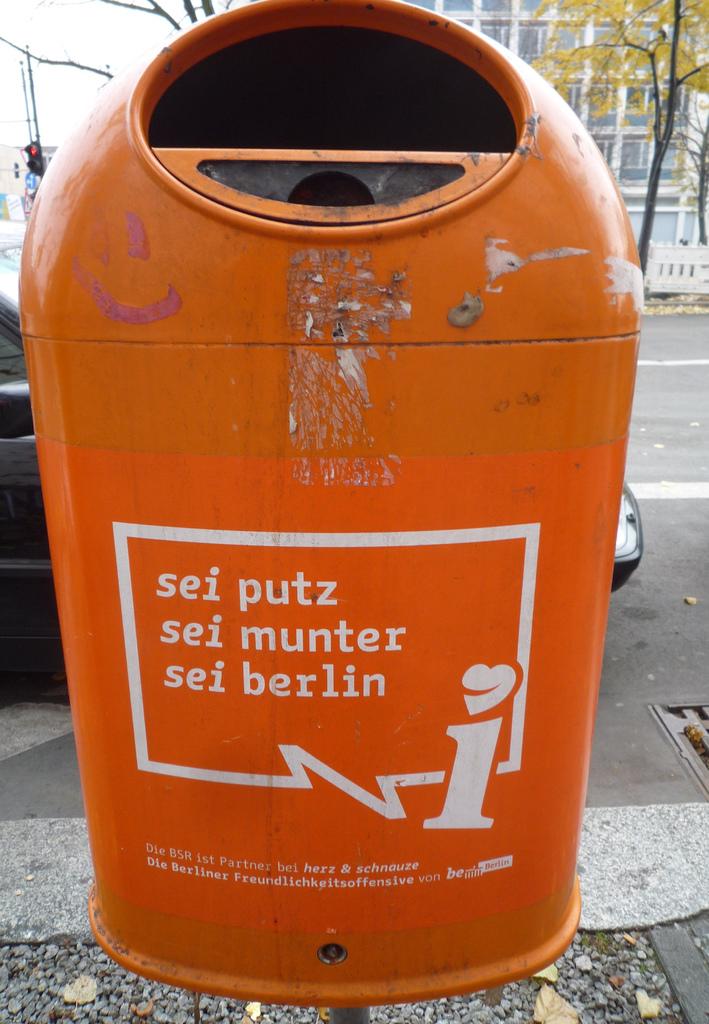Is the text on the can in english?
Provide a short and direct response. No. What city is the last word on the last sentence?
Keep it short and to the point. Berlin. 